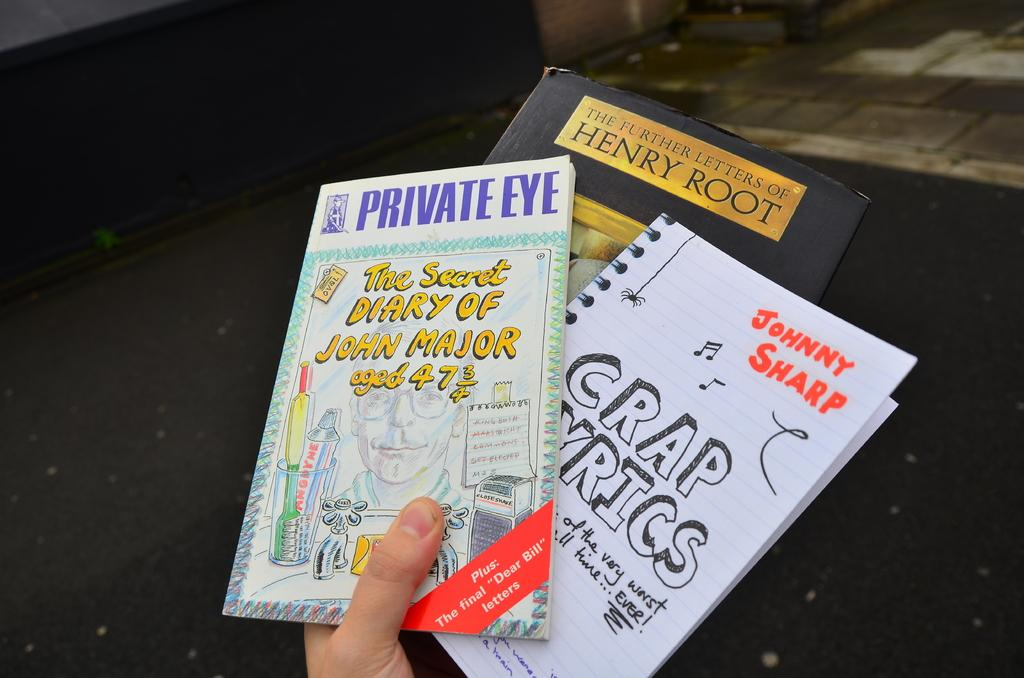<image>
Summarize the visual content of the image. A hand is holding three books and one of the books is written by Johnny Sharp. 